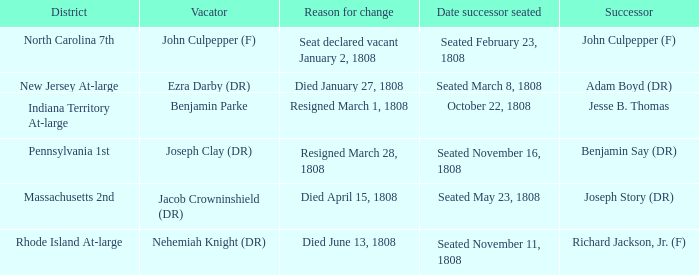Who is the successor when the reason for change is seat declared vacant January 2, 1808 John Culpepper (F). 